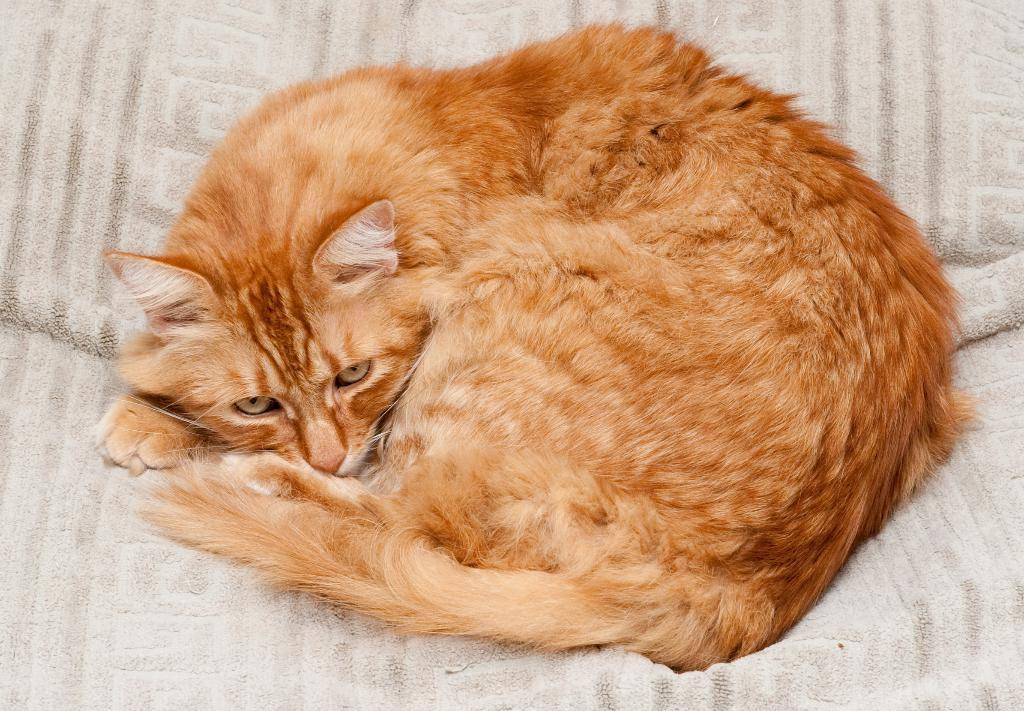What type of animal is in the image? There is a cat in the image. What is the cat sitting on? The cat is sitting on a white surface. What type of plastic object can be seen in the image? There is no plastic object present in the image; it only features a cat sitting on a white surface. 